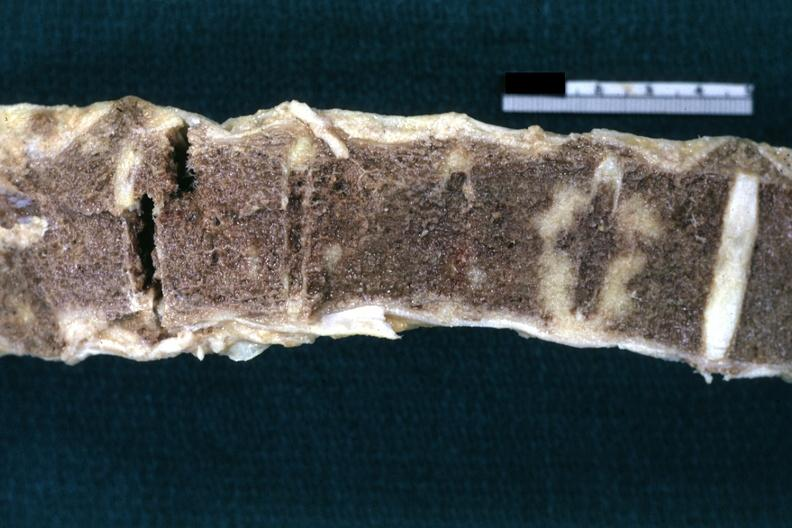s joints present?
Answer the question using a single word or phrase. Yes 